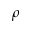<formula> <loc_0><loc_0><loc_500><loc_500>\rho</formula> 